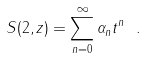<formula> <loc_0><loc_0><loc_500><loc_500>S ( 2 , z ) = \sum _ { n = 0 } ^ { \infty } \alpha _ { n } t ^ { n } \ .</formula> 